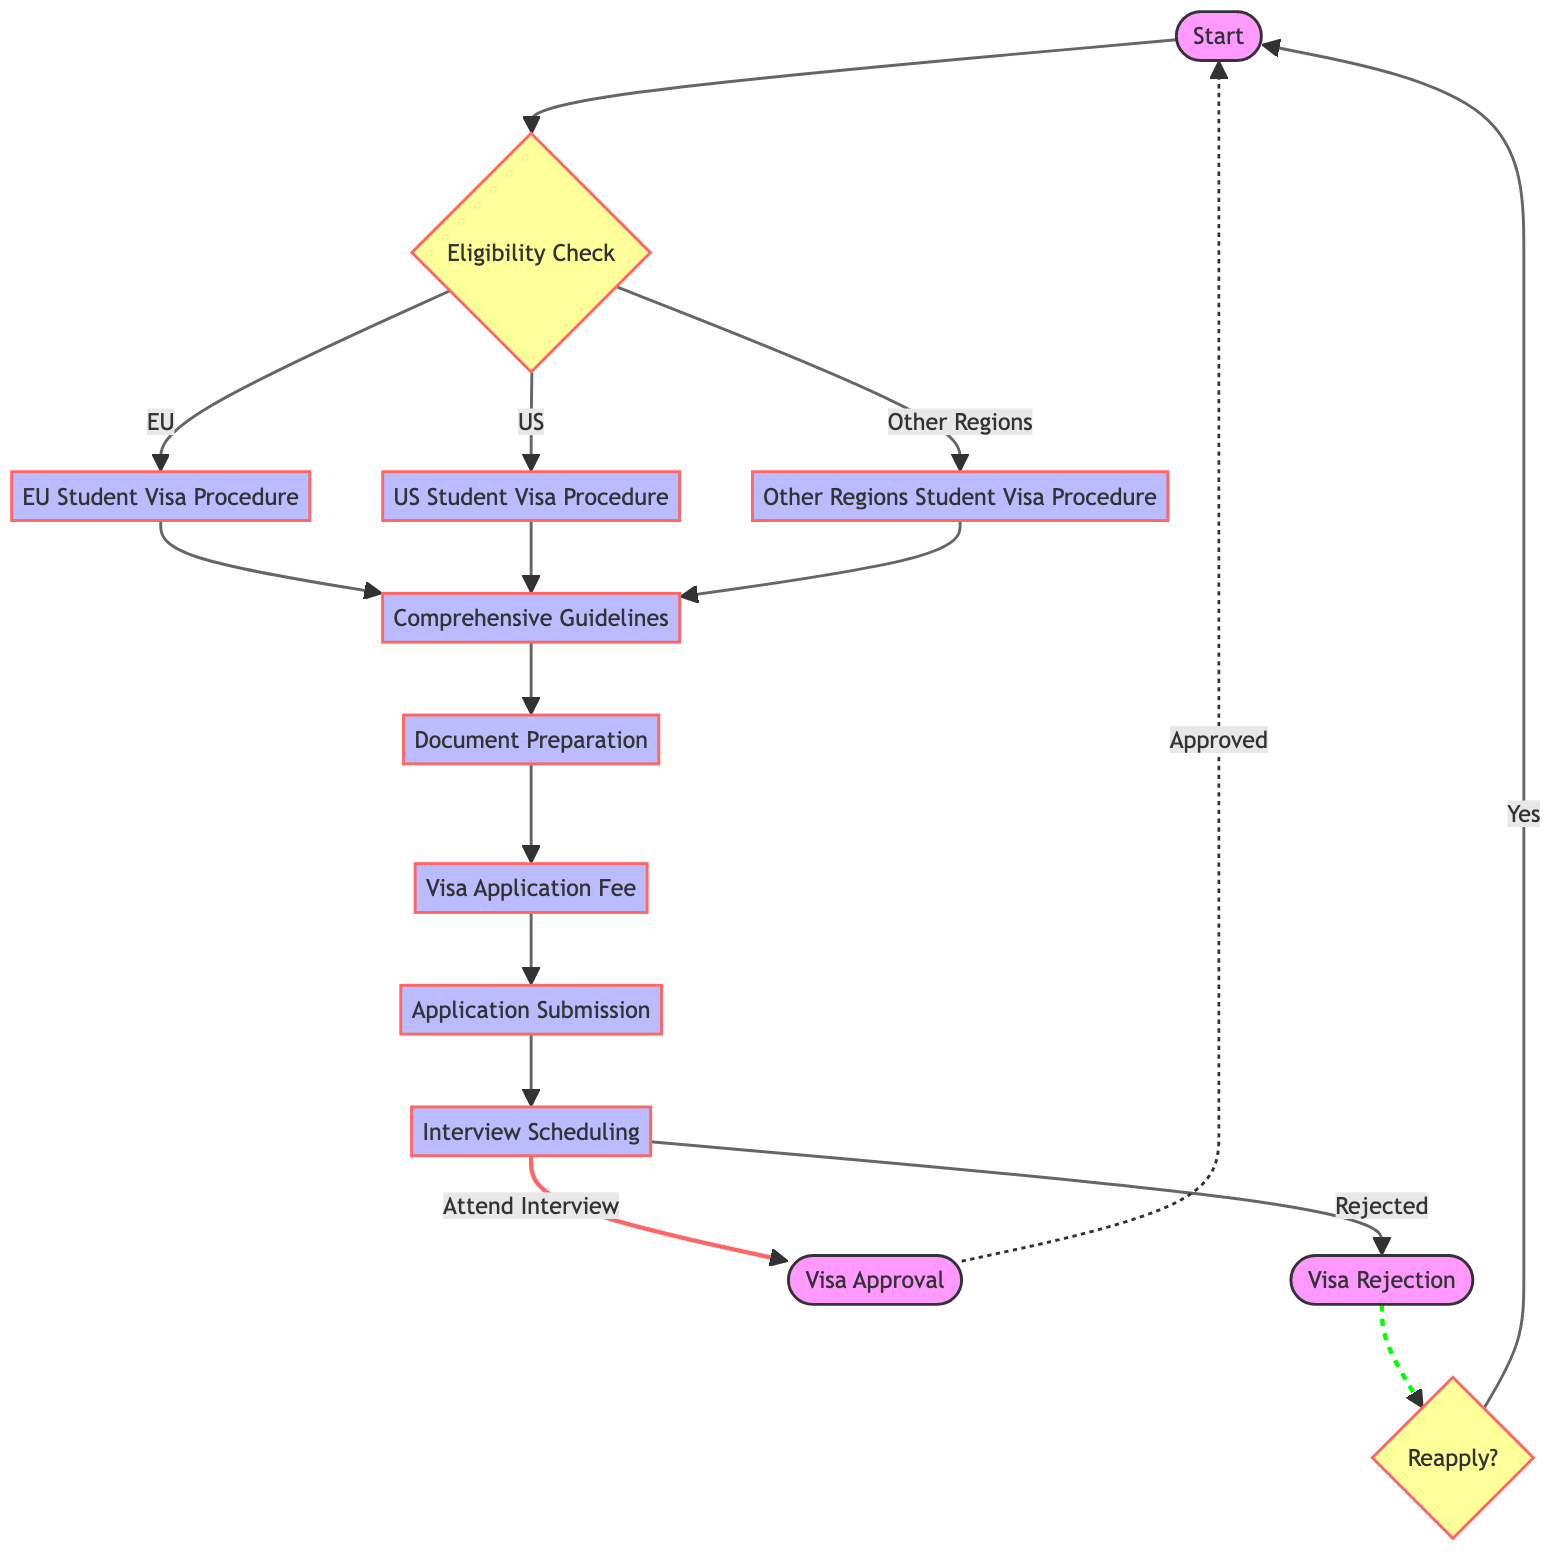What is the first step in the migration law pathway? The first step in the pathway is labeled "Start," which indicates the beginning of the process for obtaining a student visa.
Answer: Start How many procedures are outlined for student visas in the diagram? The diagram outlines three procedures: EU Student Visa Procedure, US Student Visa Procedure, and Other Regions Student Visa Procedure, making a total of three.
Answer: Three What happens after the interview scheduling? After interview scheduling, the next possible outcomes are either "Visa Approval" if the interview is attended, or "Visa Rejection" if the outcome is negative.
Answer: Visa Approval, Visa Rejection What is the decision node after visa rejection? The decision node after visa rejection is "Reapply?" This indicates that there is an option to start the process again if the visa is rejected.
Answer: Reapply? In which step is "Document Preparation" found in relation to "Comprehensive Guidelines"? "Document Preparation" follows directly after the "Comprehensive Guidelines," indicating that preparing documents is the next step after reviewing the guidelines.
Answer: After If a student attends the interview and receives a rejection, what is the next decision point? After receiving a rejection after the interview, the next decision point is whether to "Reapply?" This indicates the option for the applicant to restart the process.
Answer: Reapply? What type of node is "Eligibility Check"? "Eligibility Check" is a decision node, as indicated by its diamond shape and its role in determining the pathway based on the student's location (EU, US, Other Regions).
Answer: Decision node How does "Visa Approval" relate to the "Start" node? "Visa Approval" is a terminal point that leads back to the "Start" node, indicating that the process can begin anew once a visa is approved.
Answer: Leads back to Start 